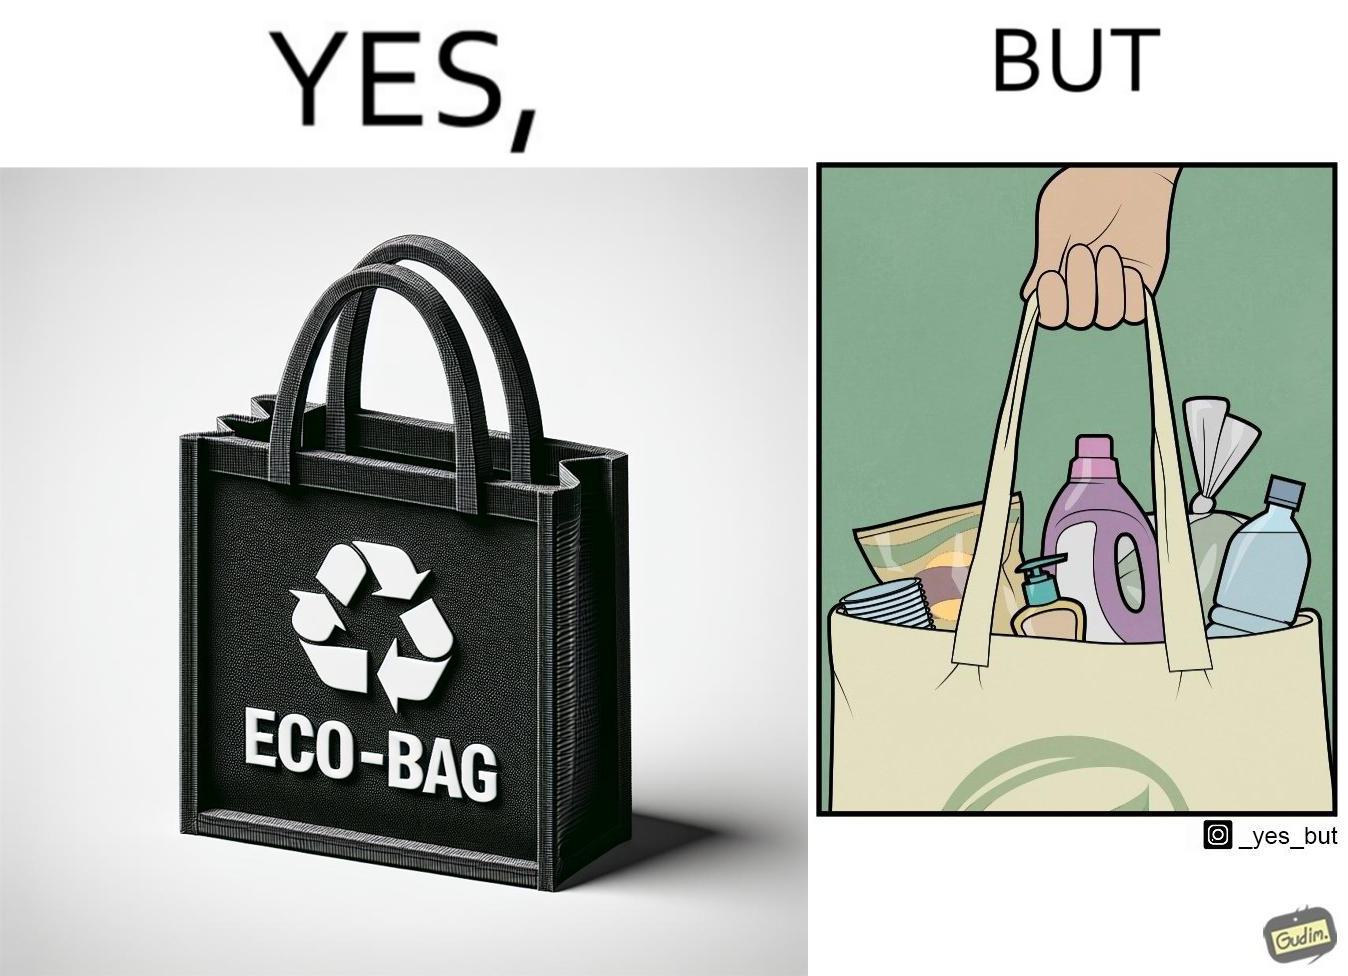Describe the content of this image. The image is ironic, because people nowadays use eco-bag thinking them as safe for the environment but in turn use products which are harmful for the environment or are packaged in some non-biodegradable material 